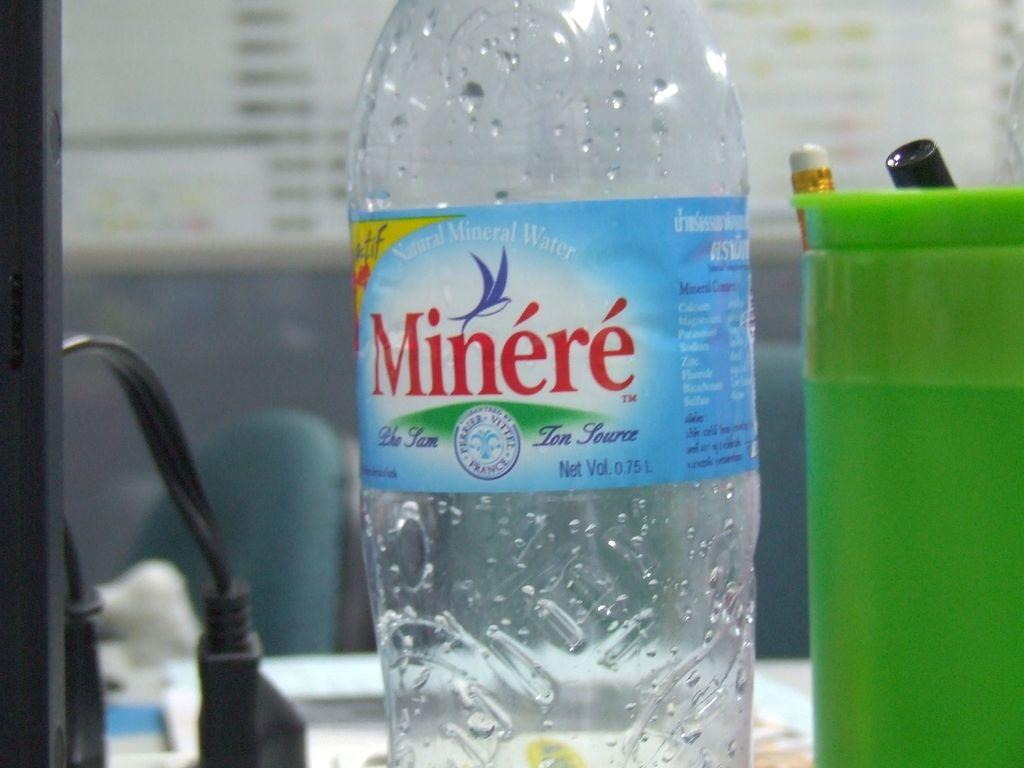<image>
Offer a succinct explanation of the picture presented. A bottle of Minere water is on a counter by a green cup with pens in it. 